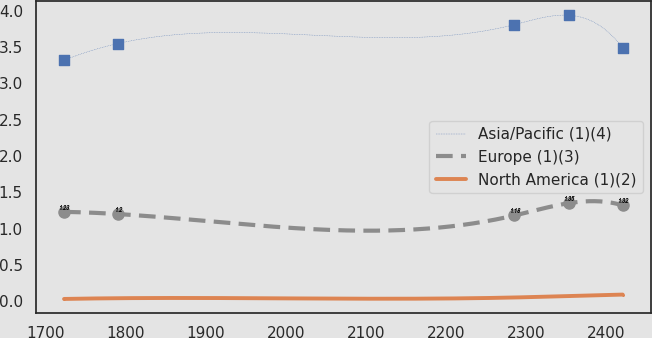Convert chart to OTSL. <chart><loc_0><loc_0><loc_500><loc_500><line_chart><ecel><fcel>Asia/Pacific (1)(4)<fcel>Europe (1)(3)<fcel>North America (1)(2)<nl><fcel>1723.21<fcel>3.32<fcel>1.23<fcel>0.03<nl><fcel>1790.39<fcel>3.55<fcel>1.2<fcel>0.04<nl><fcel>2285.36<fcel>3.81<fcel>1.18<fcel>0.05<nl><fcel>2353.39<fcel>3.94<fcel>1.35<fcel>0.07<nl><fcel>2420.57<fcel>3.49<fcel>1.32<fcel>0.09<nl></chart> 